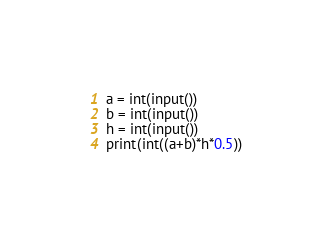Convert code to text. <code><loc_0><loc_0><loc_500><loc_500><_Python_>a = int(input())
b = int(input())
h = int(input())
print(int((a+b)*h*0.5))</code> 